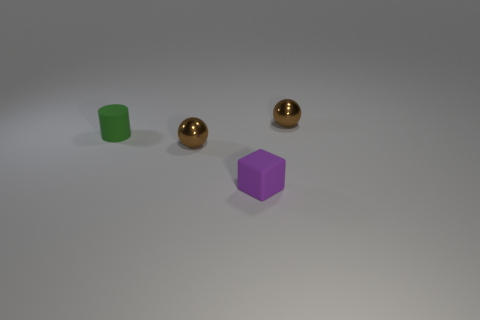Add 3 rubber cylinders. How many objects exist? 7 Subtract all cylinders. How many objects are left? 3 Subtract all purple blocks. Subtract all small green matte cylinders. How many objects are left? 2 Add 1 purple blocks. How many purple blocks are left? 2 Add 2 big gray things. How many big gray things exist? 2 Subtract 0 cyan cylinders. How many objects are left? 4 